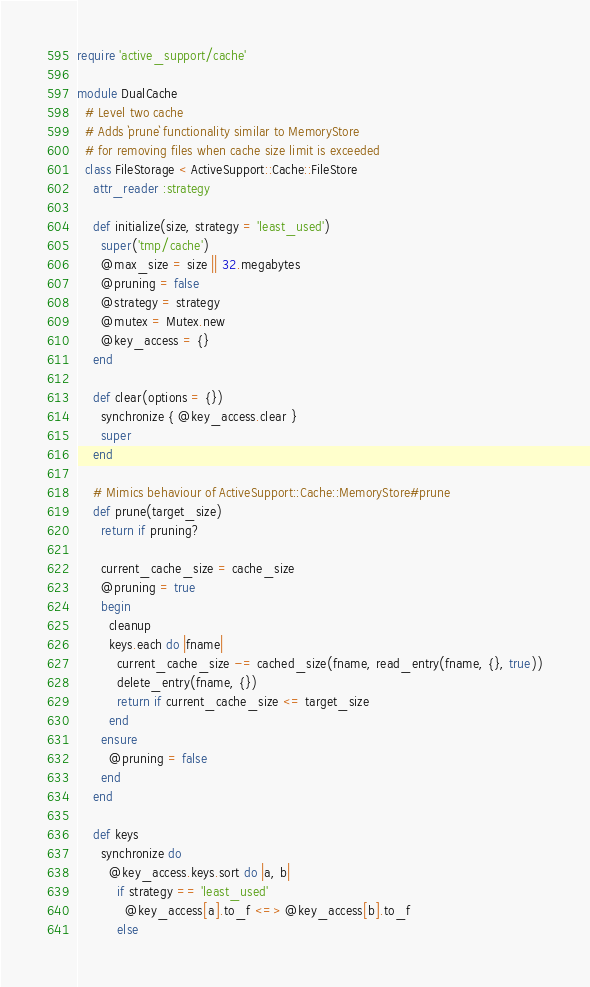Convert code to text. <code><loc_0><loc_0><loc_500><loc_500><_Ruby_>require 'active_support/cache'

module DualCache
  # Level two cache
  # Adds `prune` functionality similar to MemoryStore
  # for removing files when cache size limit is exceeded
  class FileStorage < ActiveSupport::Cache::FileStore
    attr_reader :strategy

    def initialize(size, strategy = 'least_used')
      super('tmp/cache')
      @max_size = size || 32.megabytes
      @pruning = false
      @strategy = strategy
      @mutex = Mutex.new
      @key_access = {}
    end

    def clear(options = {})
      synchronize { @key_access.clear }
      super
    end

    # Mimics behaviour of ActiveSupport::Cache::MemoryStore#prune
    def prune(target_size)
      return if pruning?

      current_cache_size = cache_size
      @pruning = true
      begin
        cleanup
        keys.each do |fname|
          current_cache_size -= cached_size(fname, read_entry(fname, {}, true))
          delete_entry(fname, {})
          return if current_cache_size <= target_size
        end
      ensure
        @pruning = false
      end
    end

    def keys
      synchronize do
        @key_access.keys.sort do |a, b|
          if strategy == 'least_used'
            @key_access[a].to_f <=> @key_access[b].to_f
          else</code> 